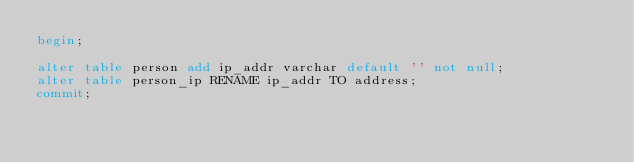<code> <loc_0><loc_0><loc_500><loc_500><_SQL_>begin;

alter table person add ip_addr varchar default '' not null;
alter table person_ip RENAME ip_addr TO address;
commit;</code> 